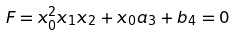<formula> <loc_0><loc_0><loc_500><loc_500>F = x _ { 0 } ^ { 2 } x _ { 1 } x _ { 2 } + x _ { 0 } a _ { 3 } + b _ { 4 } = 0</formula> 